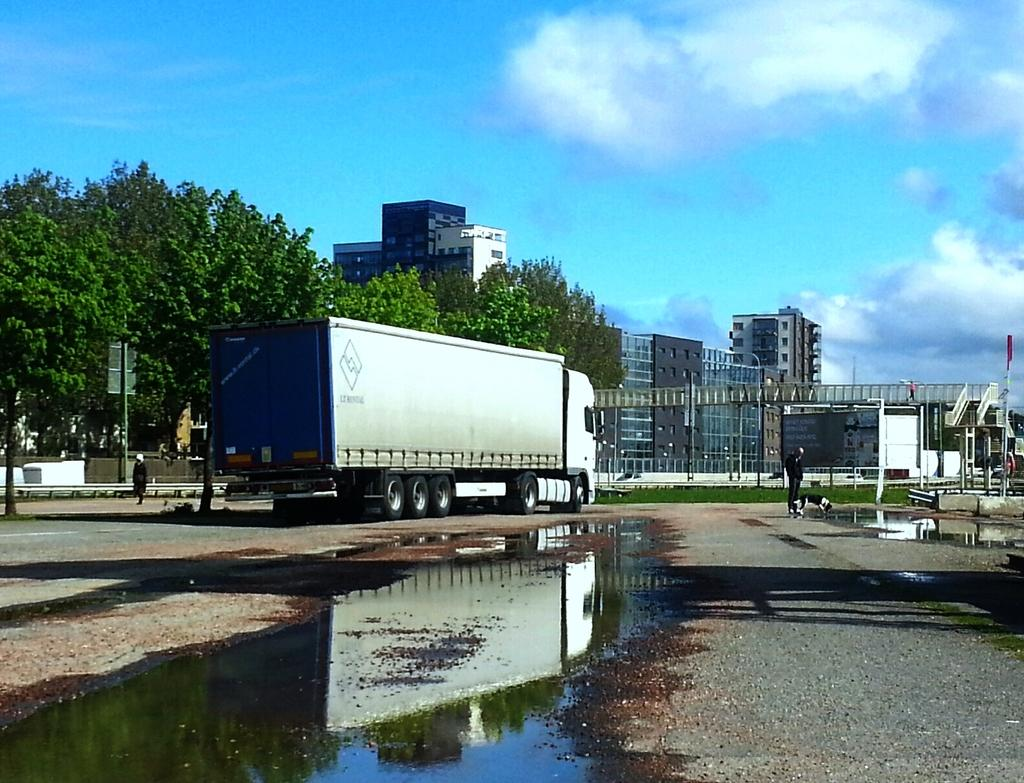What type of structures can be seen in the image? There are buildings in the image. What other objects are present in the image? There are poles, a board, people, a vehicle, water, trees, and unspecified objects in the image. What is the condition of the sky in the image? The sky is cloudy in the image. Can you tell me what picture the man is holding in the image? There is no man present in the image, so it is not possible to determine what picture he might be holding. What type of horn can be seen on the vehicle in the image? There is no horn visible on the vehicle in the image. 